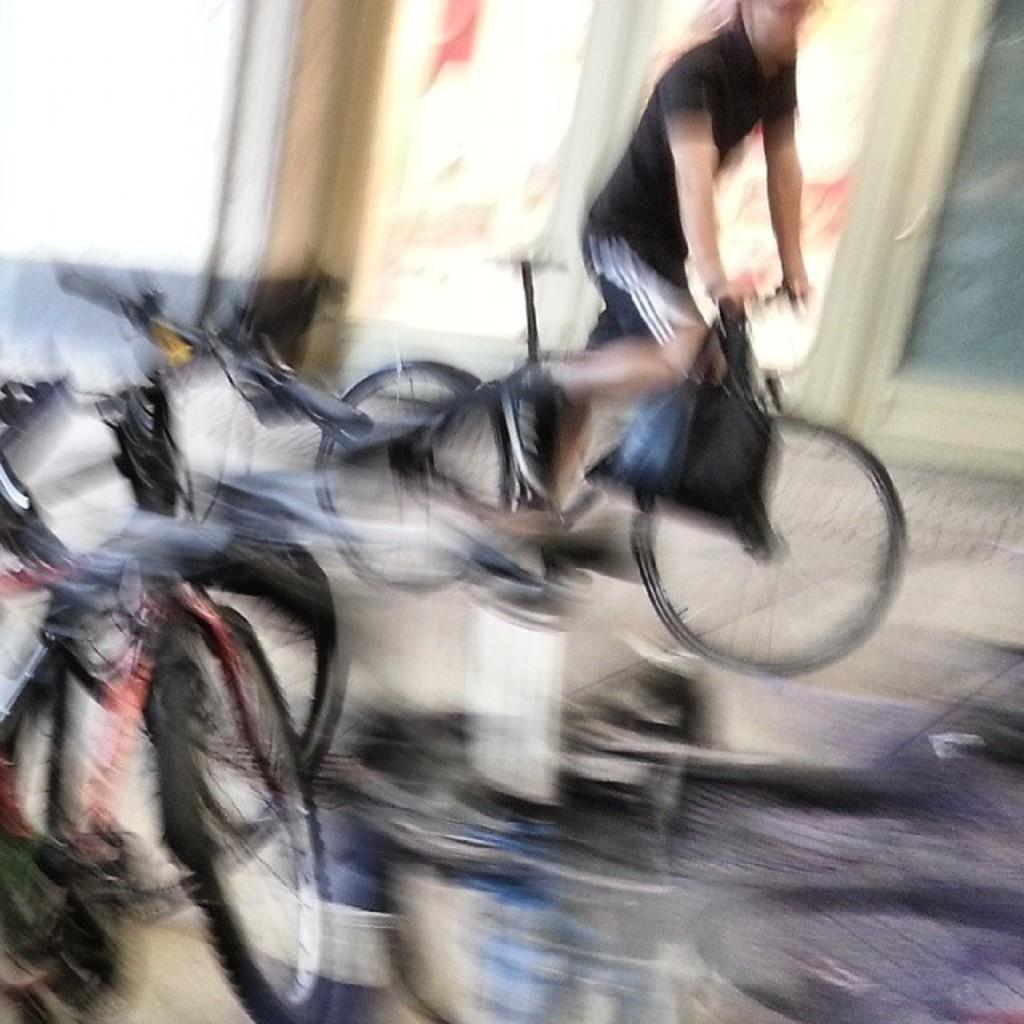What is the main subject of the picture? There is a person in the picture. What is the person doing in the image? The person is cycling a bicycle. Where is the bicycle located in the image? The bicycle is on the road. Are there any other bicycles visible in the image? Yes, there is another bicycle on the left side. What can be seen in the background of the image? There is a door and a wall in the background. What type of root can be seen growing near the door in the image? There is no root visible in the image; only a door and a wall are present in the background. 